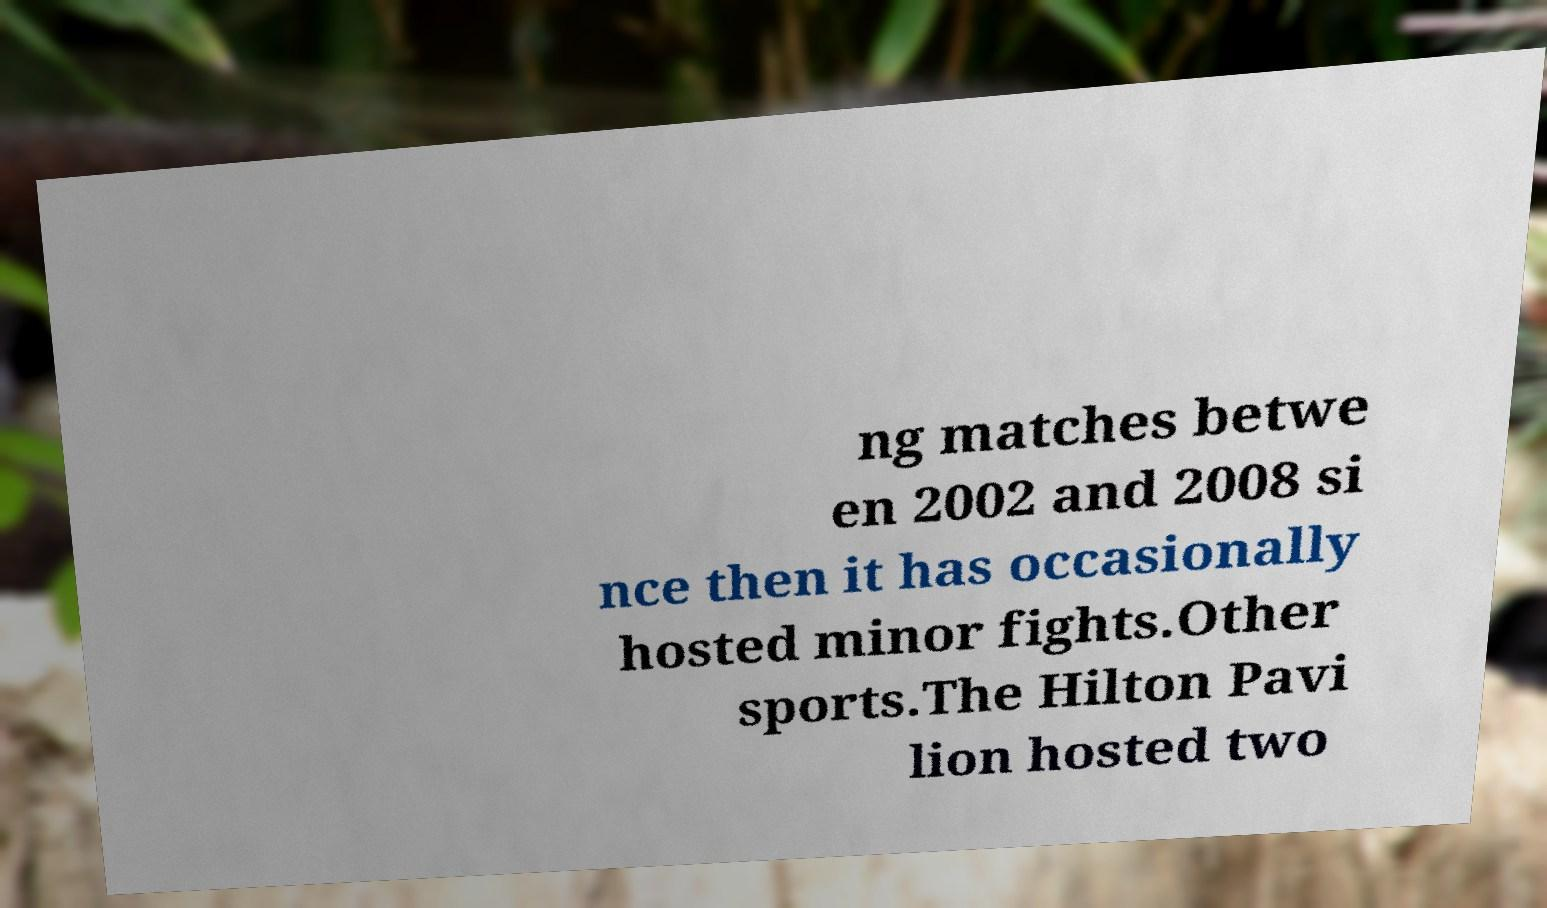Please read and relay the text visible in this image. What does it say? ng matches betwe en 2002 and 2008 si nce then it has occasionally hosted minor fights.Other sports.The Hilton Pavi lion hosted two 